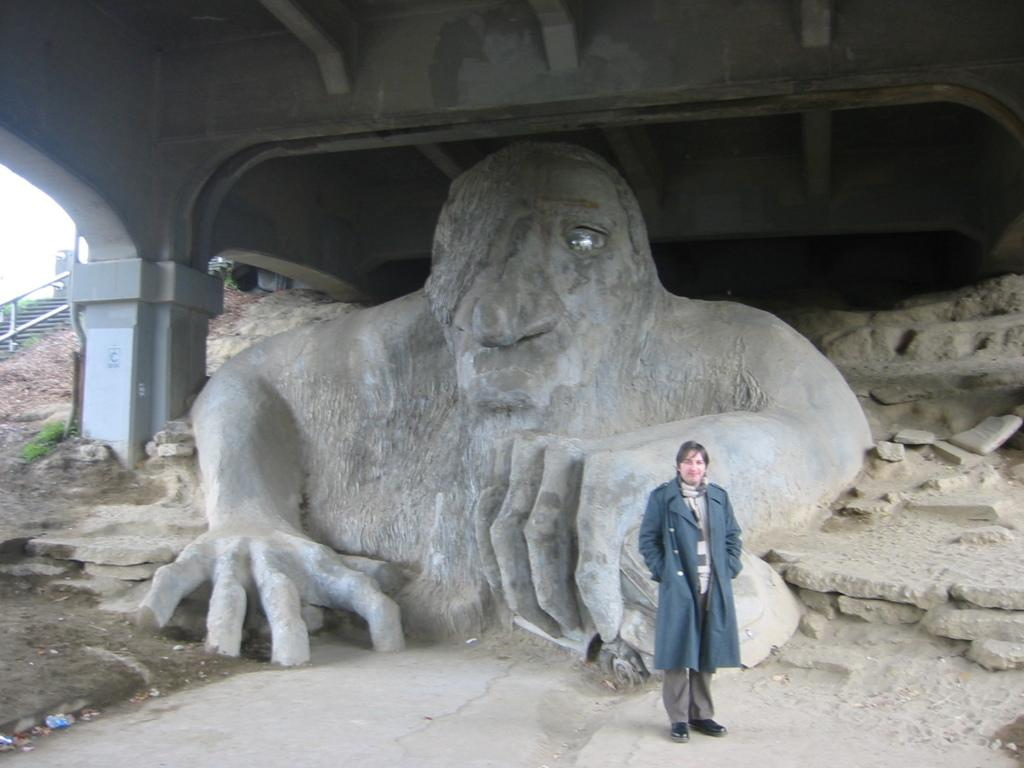What is the main subject in the foreground of the picture? There is a person standing in the foreground of the picture. What can be seen in the center of the image? There is a sculpture in the center of the image. What architectural feature is visible in the background of the image? There is a staircase in the background of the image, to the left. What structure can be seen at the top of the image? There is a bridge at the top of the image. What type of sound can be heard coming from the person's feet in the image? There is no sound coming from the person's feet in the image, as it is a still photograph. What type of coach is present in the image? There is no coach present in the image. 